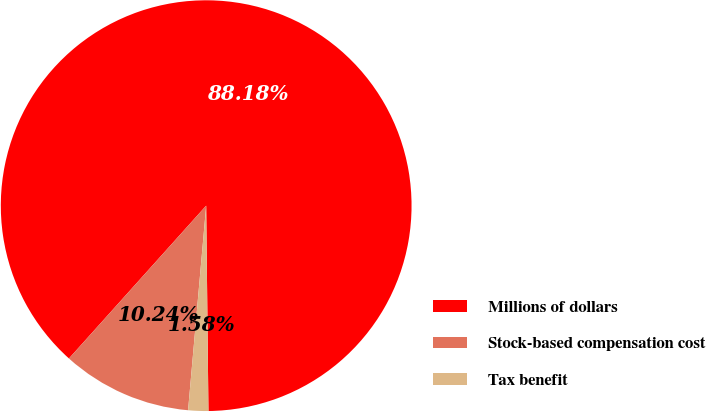Convert chart. <chart><loc_0><loc_0><loc_500><loc_500><pie_chart><fcel>Millions of dollars<fcel>Stock-based compensation cost<fcel>Tax benefit<nl><fcel>88.18%<fcel>10.24%<fcel>1.58%<nl></chart> 